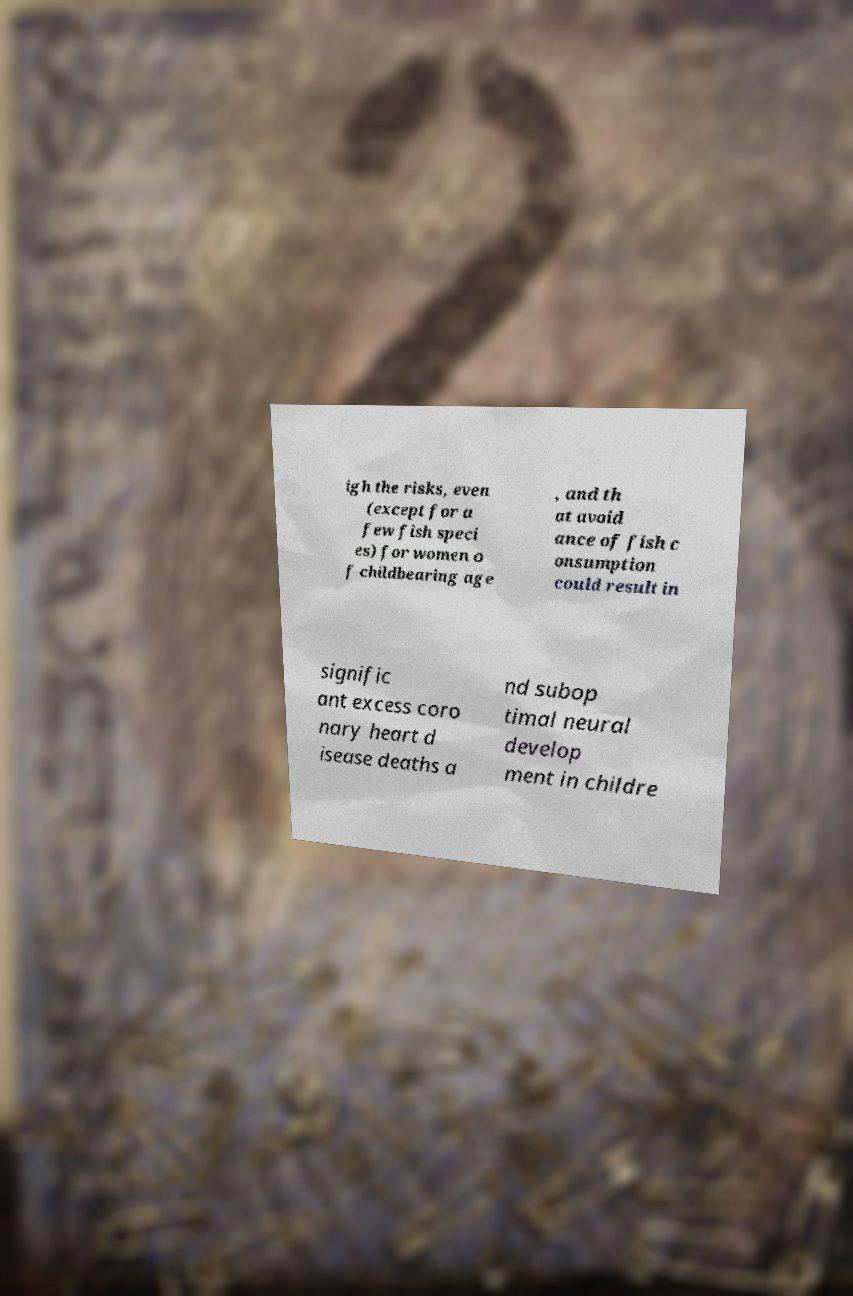I need the written content from this picture converted into text. Can you do that? igh the risks, even (except for a few fish speci es) for women o f childbearing age , and th at avoid ance of fish c onsumption could result in signific ant excess coro nary heart d isease deaths a nd subop timal neural develop ment in childre 